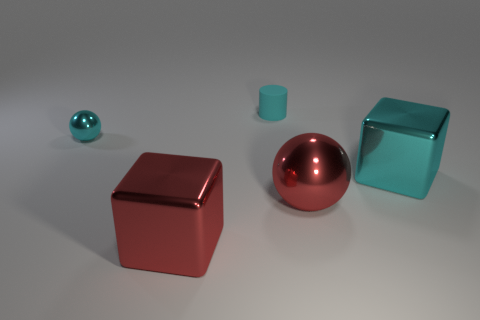Are there fewer shiny objects on the right side of the cyan ball than red shiny cubes?
Your answer should be very brief. No. What is the color of the metal object on the right side of the large red shiny object that is behind the large thing left of the rubber cylinder?
Your answer should be very brief. Cyan. Is there anything else that has the same material as the cyan sphere?
Your response must be concise. Yes. There is a red shiny object that is the same shape as the small cyan metallic object; what is its size?
Provide a short and direct response. Large. Are there fewer large shiny things left of the big cyan thing than tiny cyan metallic things that are behind the cylinder?
Make the answer very short. No. There is a large shiny thing that is both to the left of the big cyan block and on the right side of the small cyan cylinder; what shape is it?
Offer a terse response. Sphere. There is another ball that is the same material as the cyan sphere; what is its size?
Provide a short and direct response. Large. Do the big ball and the thing behind the tiny cyan sphere have the same color?
Give a very brief answer. No. What is the large object that is both in front of the cyan cube and right of the matte cylinder made of?
Provide a succinct answer. Metal. There is a sphere that is the same color as the tiny rubber cylinder; what size is it?
Your response must be concise. Small. 